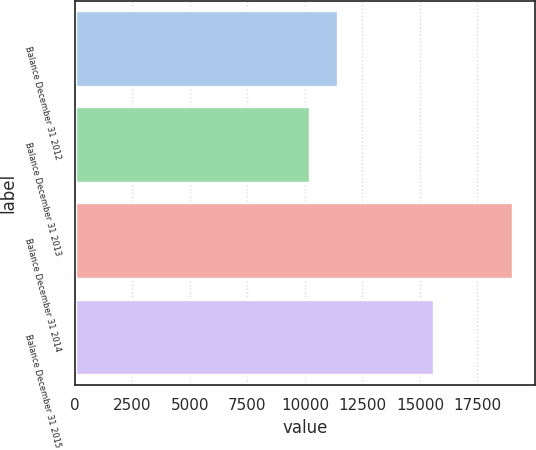Convert chart to OTSL. <chart><loc_0><loc_0><loc_500><loc_500><bar_chart><fcel>Balance December 31 2012<fcel>Balance December 31 2013<fcel>Balance December 31 2014<fcel>Balance December 31 2015<nl><fcel>11433<fcel>10231<fcel>19047<fcel>15627<nl></chart> 